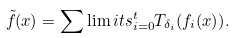Convert formula to latex. <formula><loc_0><loc_0><loc_500><loc_500>\tilde { f } ( x ) = \sum \lim i t s _ { i = 0 } ^ { t } { T _ { \delta _ { i } } ( f _ { i } ( x ) ) } .</formula> 